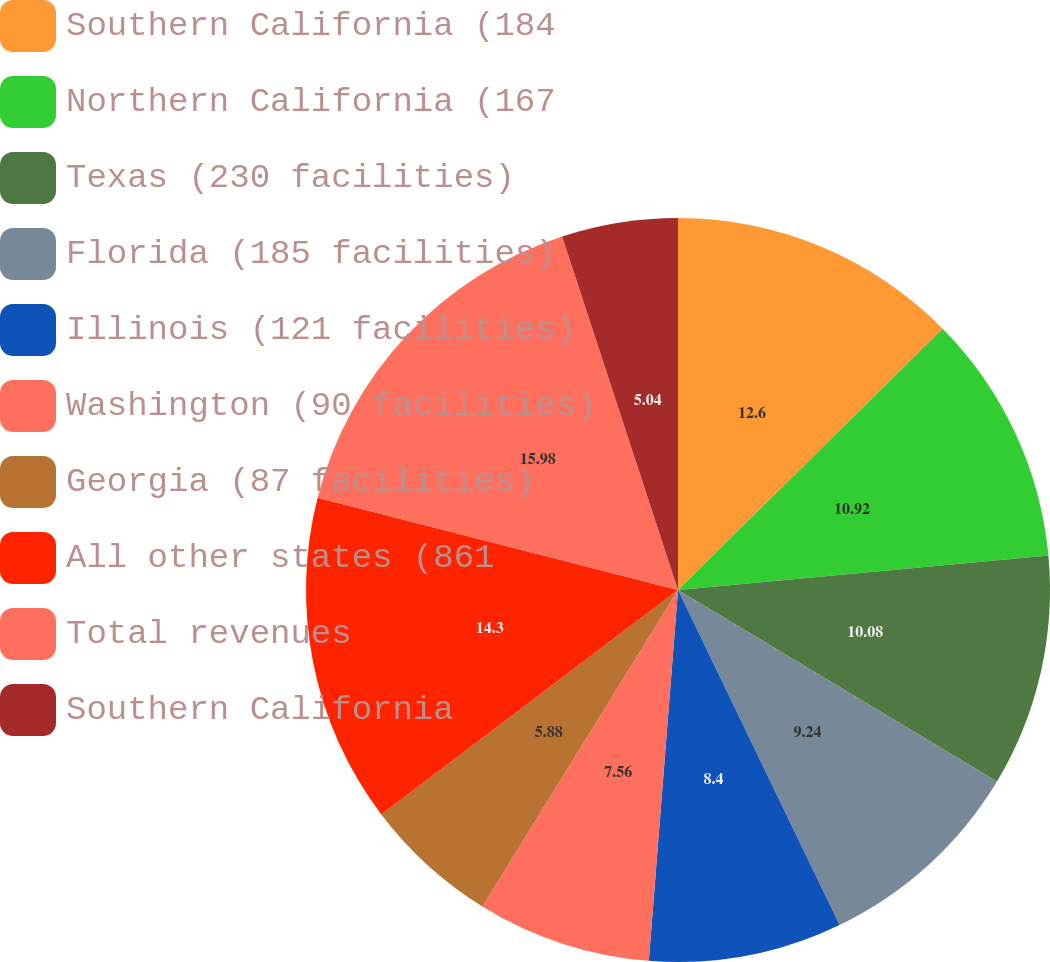Convert chart to OTSL. <chart><loc_0><loc_0><loc_500><loc_500><pie_chart><fcel>Southern California (184<fcel>Northern California (167<fcel>Texas (230 facilities)<fcel>Florida (185 facilities)<fcel>Illinois (121 facilities)<fcel>Washington (90 facilities)<fcel>Georgia (87 facilities)<fcel>All other states (861<fcel>Total revenues<fcel>Southern California<nl><fcel>12.6%<fcel>10.92%<fcel>10.08%<fcel>9.24%<fcel>8.4%<fcel>7.56%<fcel>5.88%<fcel>14.29%<fcel>15.97%<fcel>5.04%<nl></chart> 